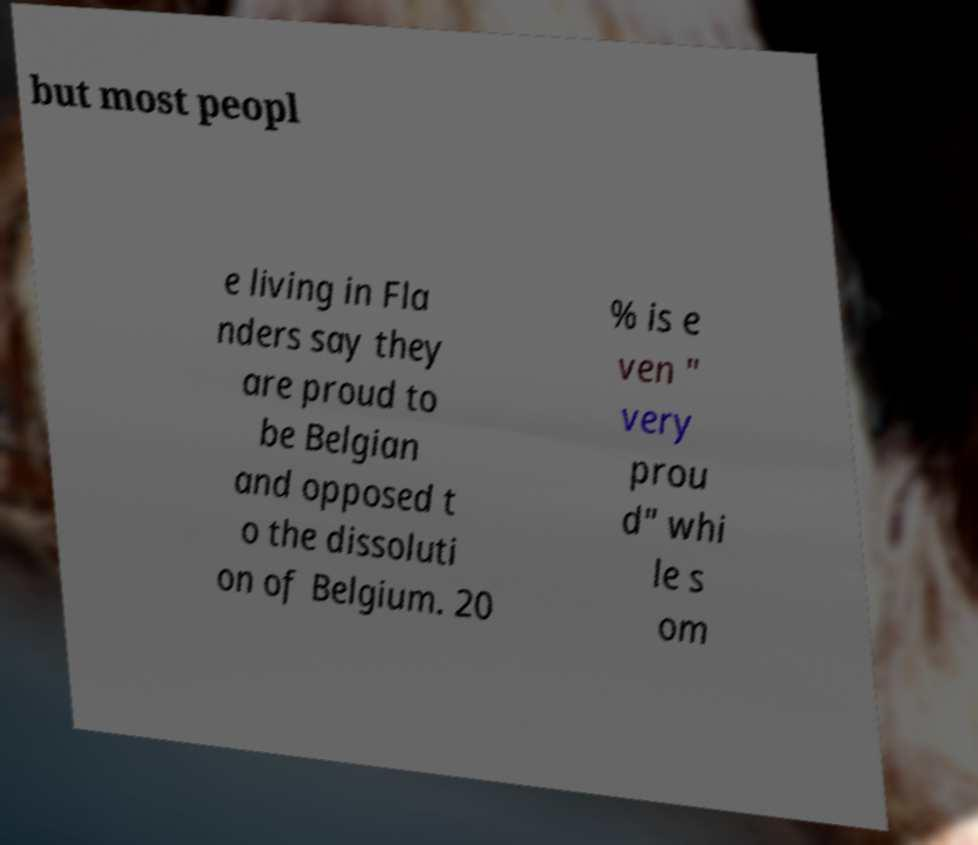Could you assist in decoding the text presented in this image and type it out clearly? but most peopl e living in Fla nders say they are proud to be Belgian and opposed t o the dissoluti on of Belgium. 20 % is e ven " very prou d" whi le s om 